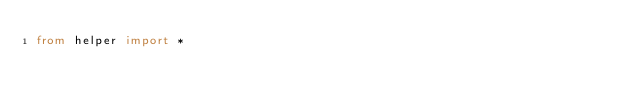<code> <loc_0><loc_0><loc_500><loc_500><_Python_>from helper import *
</code> 